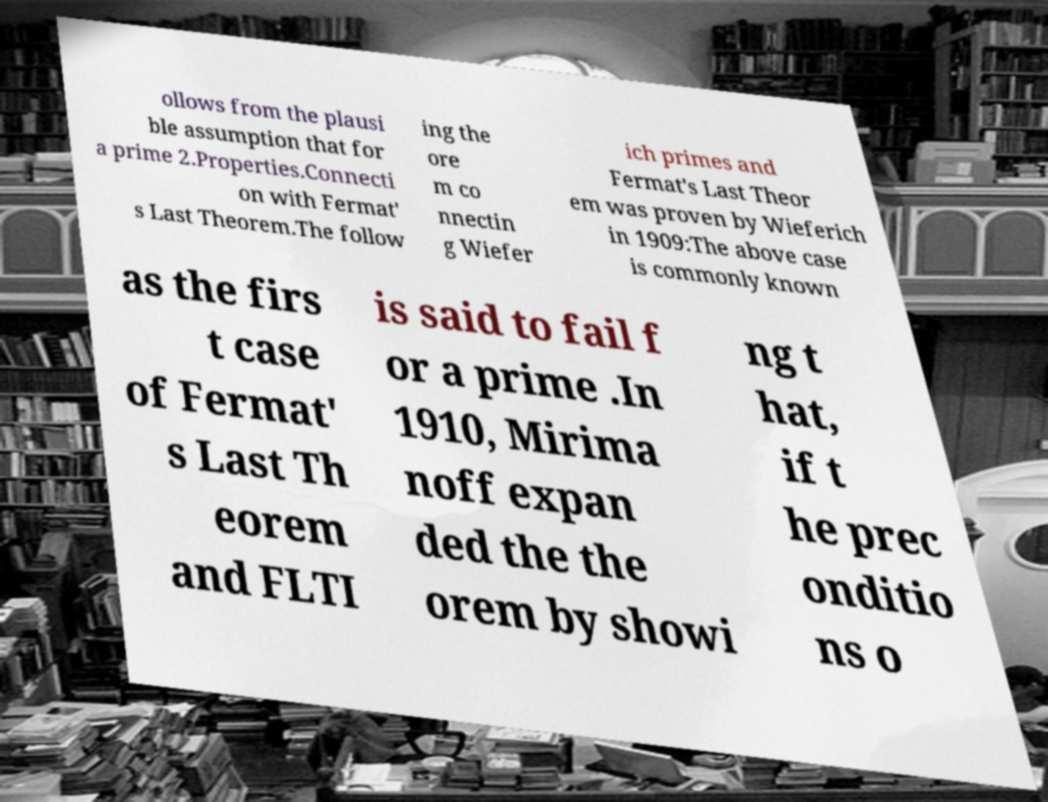What messages or text are displayed in this image? I need them in a readable, typed format. ollows from the plausi ble assumption that for a prime 2.Properties.Connecti on with Fermat' s Last Theorem.The follow ing the ore m co nnectin g Wiefer ich primes and Fermat's Last Theor em was proven by Wieferich in 1909:The above case is commonly known as the firs t case of Fermat' s Last Th eorem and FLTI is said to fail f or a prime .In 1910, Mirima noff expan ded the the orem by showi ng t hat, if t he prec onditio ns o 